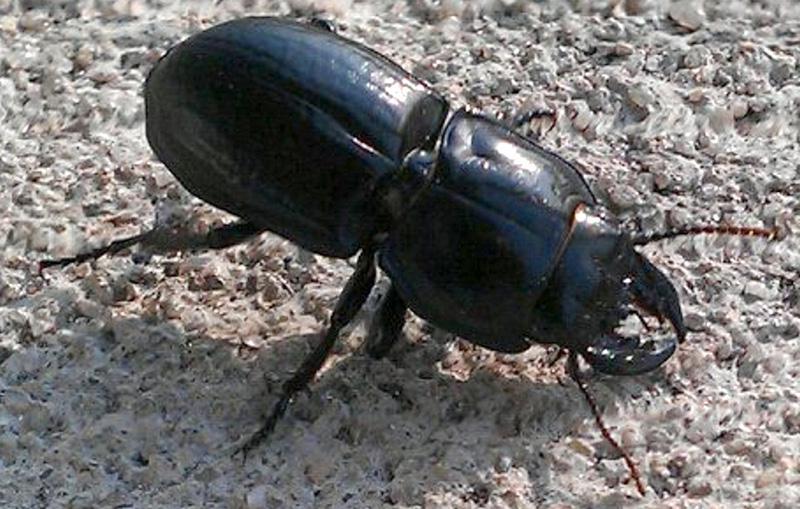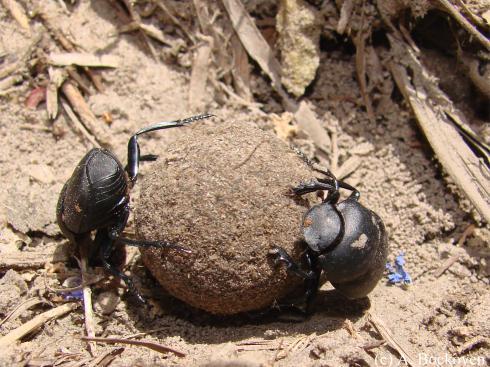The first image is the image on the left, the second image is the image on the right. Evaluate the accuracy of this statement regarding the images: "There are at most three beetles.". Is it true? Answer yes or no. Yes. The first image is the image on the left, the second image is the image on the right. Considering the images on both sides, is "One image contains a black beetle but no brown ball, and the other contains one brown ball and at least one beetle." valid? Answer yes or no. Yes. 